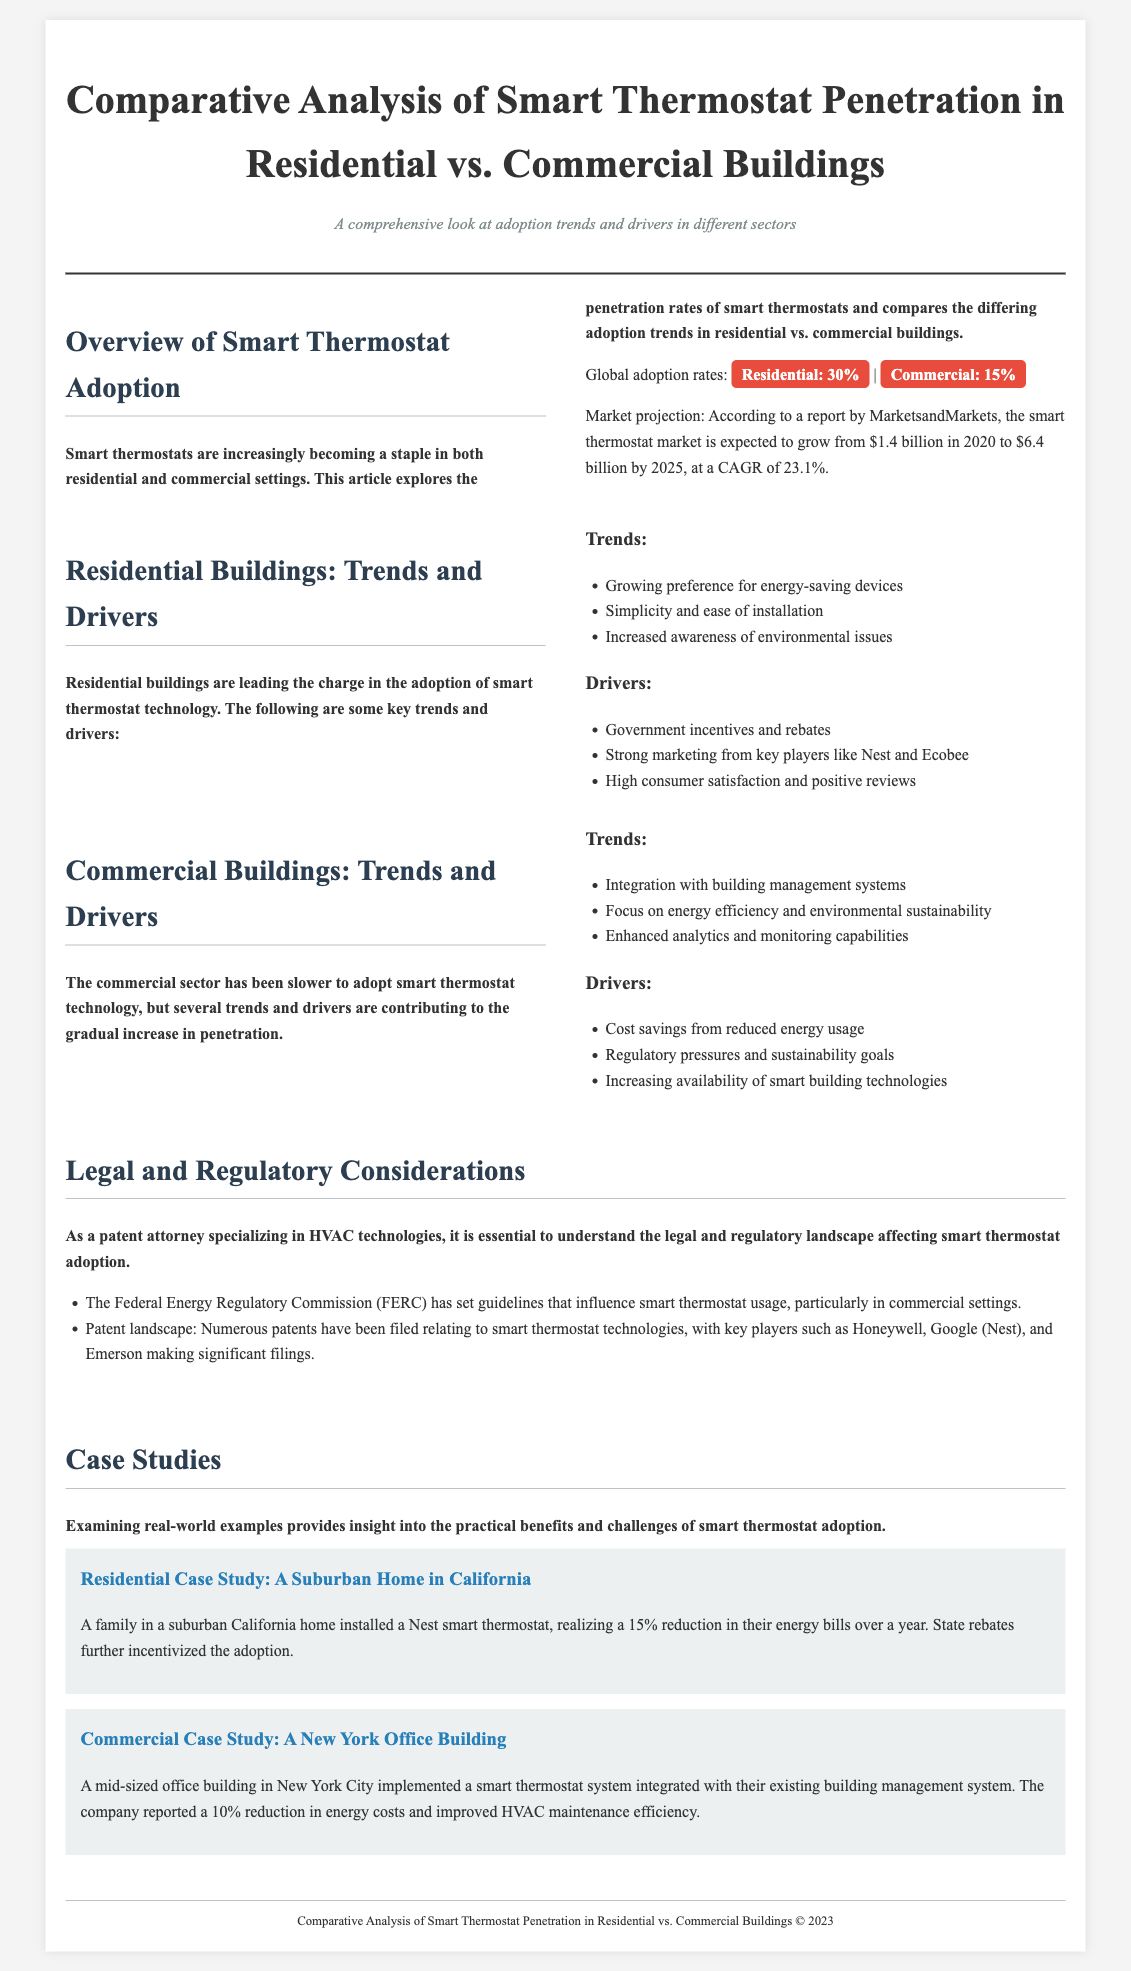What is the global adoption rate of smart thermostats in residential buildings? The document states that the global adoption rate of smart thermostats in residential buildings is 30%.
Answer: 30% What is the projected market value of smart thermostats by 2025? According to the document, the smart thermostat market is expected to grow to $6.4 billion by 2025.
Answer: $6.4 billion What trend is driving residential buildings' adoption of smart thermostats? The document lists several trends, one of which is the growing preference for energy-saving devices.
Answer: Energy-saving devices What is the adoption rate of smart thermostats in commercial buildings? The document specifies that the adoption rate of smart thermostats in commercial buildings is 15%.
Answer: 15% What are the key players making significant patent filings in smart thermostat technologies? The document mentions key players like Honeywell, Google (Nest), and Emerson in relation to patent filings.
Answer: Honeywell, Google (Nest), Emerson Which case study showed a 15% reduction in energy bills? The document refers to a suburban home in California as the case study that reported a 15% reduction in energy bills.
Answer: A Suburban Home in California What is one of the drivers for smart thermostat adoption in commercial buildings? The document states that cost savings from reduced energy usage is one of the drivers for adoption in commercial buildings.
Answer: Cost savings What is the format of the publication containing the analysis? The document follows a newspaper layout style, focusing on an informative and organized structure.
Answer: Newspaper layout What is the percentage growth rate of the smart thermostat market mentioned in the document? The document states a compound annual growth rate (CAGR) of 23.1% for the smart thermostat market.
Answer: 23.1% 